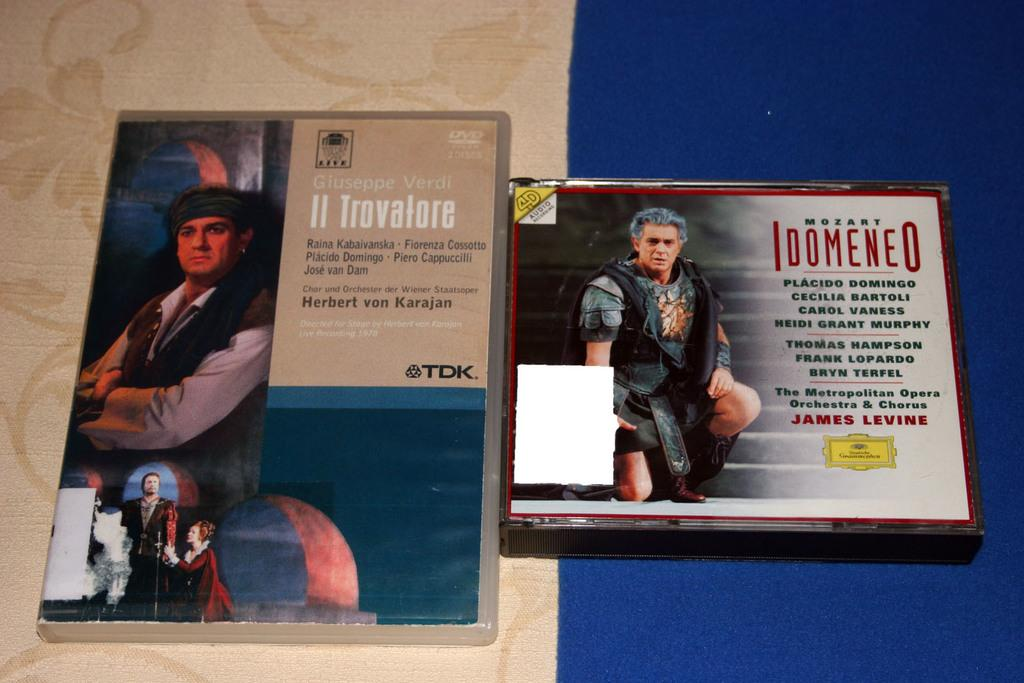<image>
Relay a brief, clear account of the picture shown. A DVD and a CD, featuring music by Mozart, are sitting side by side 